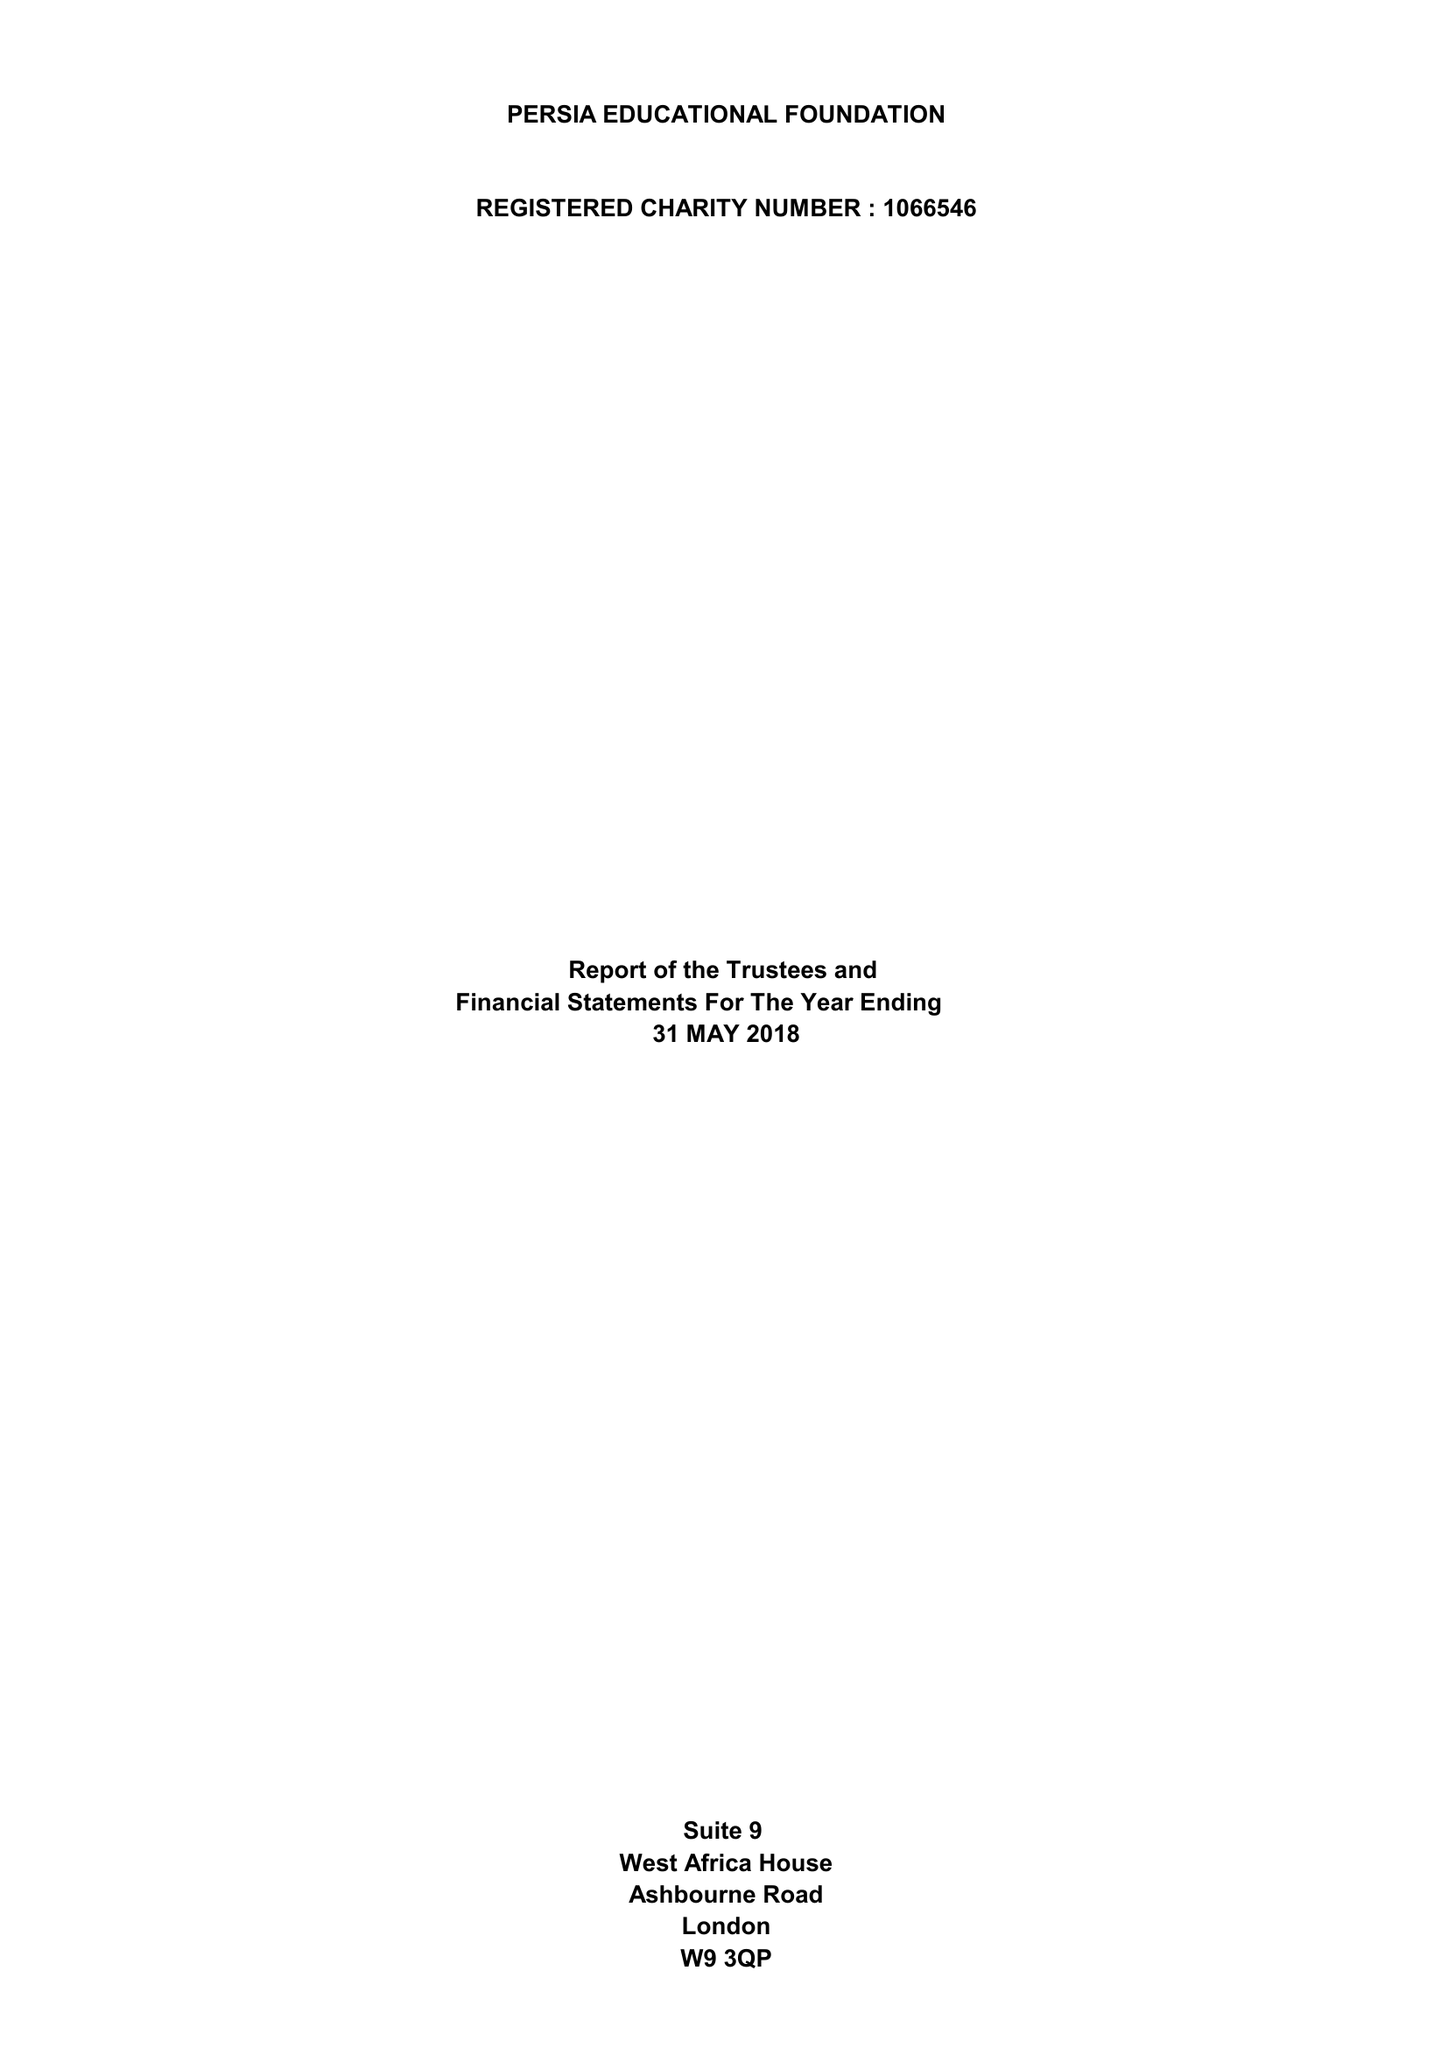What is the value for the spending_annually_in_british_pounds?
Answer the question using a single word or phrase. 64468.00 